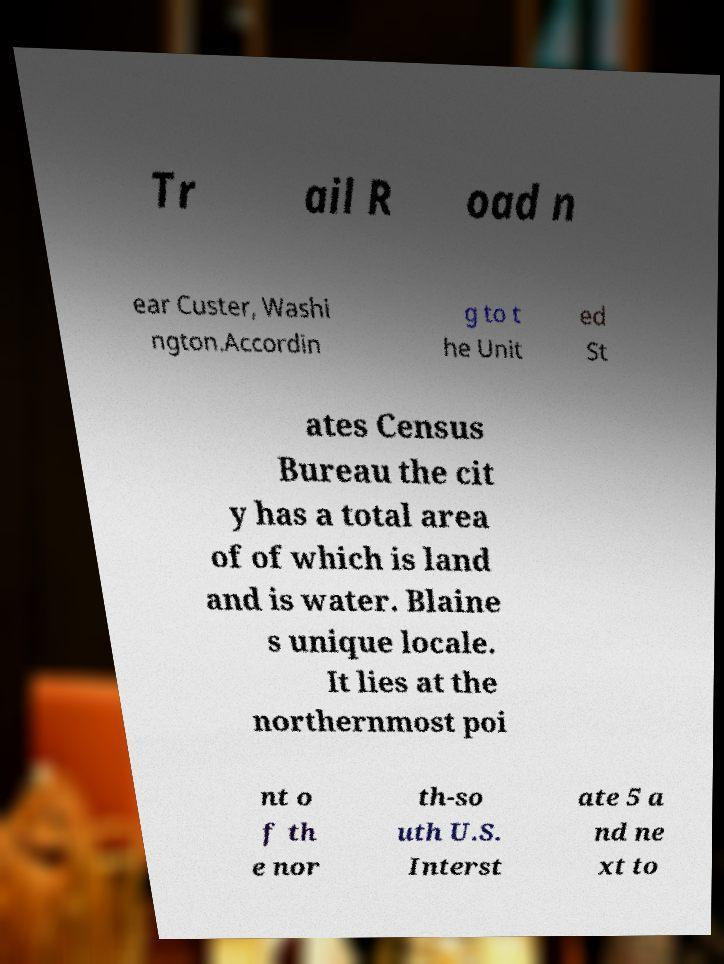I need the written content from this picture converted into text. Can you do that? Tr ail R oad n ear Custer, Washi ngton.Accordin g to t he Unit ed St ates Census Bureau the cit y has a total area of of which is land and is water. Blaine s unique locale. It lies at the northernmost poi nt o f th e nor th-so uth U.S. Interst ate 5 a nd ne xt to 